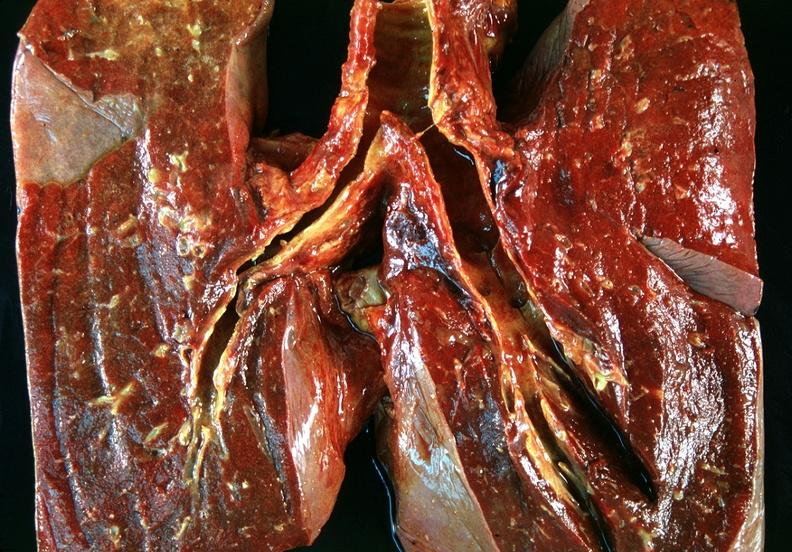where is this?
Answer the question using a single word or phrase. Lung 